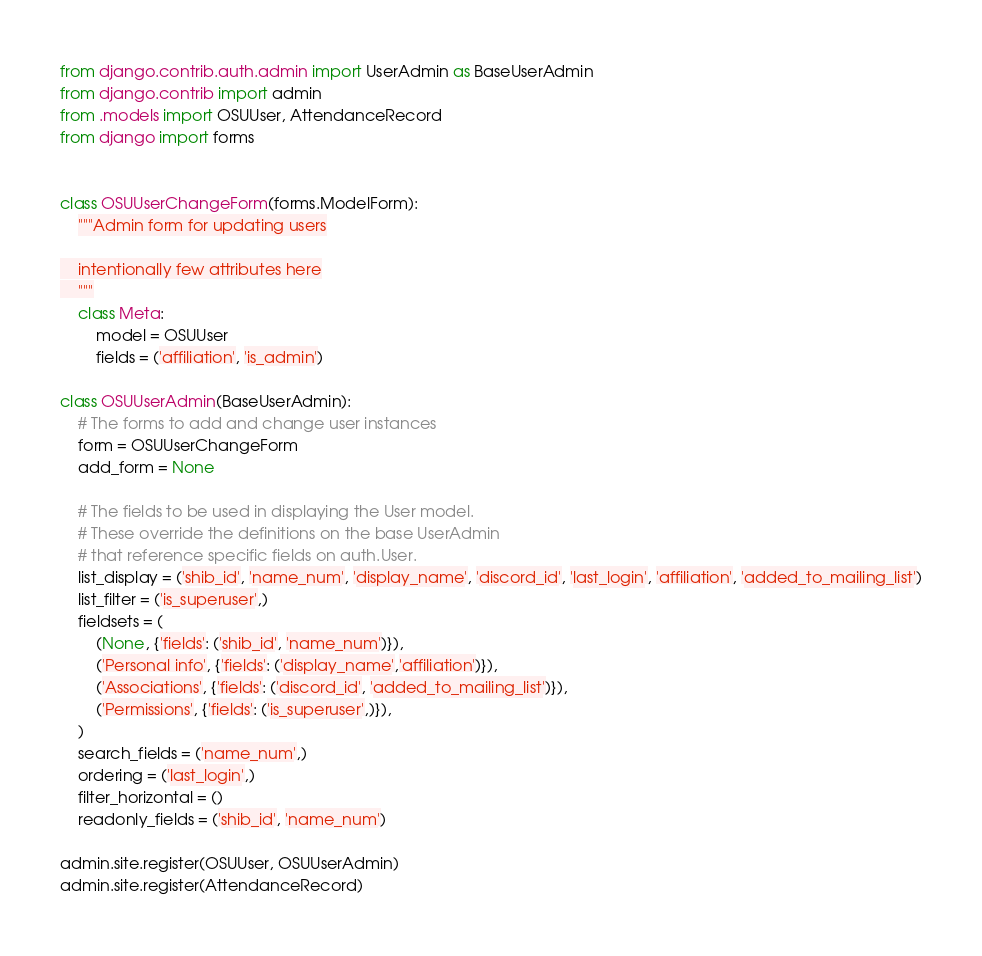<code> <loc_0><loc_0><loc_500><loc_500><_Python_>from django.contrib.auth.admin import UserAdmin as BaseUserAdmin
from django.contrib import admin
from .models import OSUUser, AttendanceRecord
from django import forms


class OSUUserChangeForm(forms.ModelForm):
    """Admin form for updating users

    intentionally few attributes here
    """
    class Meta:
        model = OSUUser
        fields = ('affiliation', 'is_admin')

class OSUUserAdmin(BaseUserAdmin):
    # The forms to add and change user instances
    form = OSUUserChangeForm
    add_form = None

    # The fields to be used in displaying the User model.
    # These override the definitions on the base UserAdmin
    # that reference specific fields on auth.User.
    list_display = ('shib_id', 'name_num', 'display_name', 'discord_id', 'last_login', 'affiliation', 'added_to_mailing_list')
    list_filter = ('is_superuser',)
    fieldsets = (
        (None, {'fields': ('shib_id', 'name_num')}),
        ('Personal info', {'fields': ('display_name','affiliation')}),
        ('Associations', {'fields': ('discord_id', 'added_to_mailing_list')}),
        ('Permissions', {'fields': ('is_superuser',)}),
    )
    search_fields = ('name_num',)
    ordering = ('last_login',)
    filter_horizontal = ()
    readonly_fields = ('shib_id', 'name_num')

admin.site.register(OSUUser, OSUUserAdmin)
admin.site.register(AttendanceRecord)</code> 